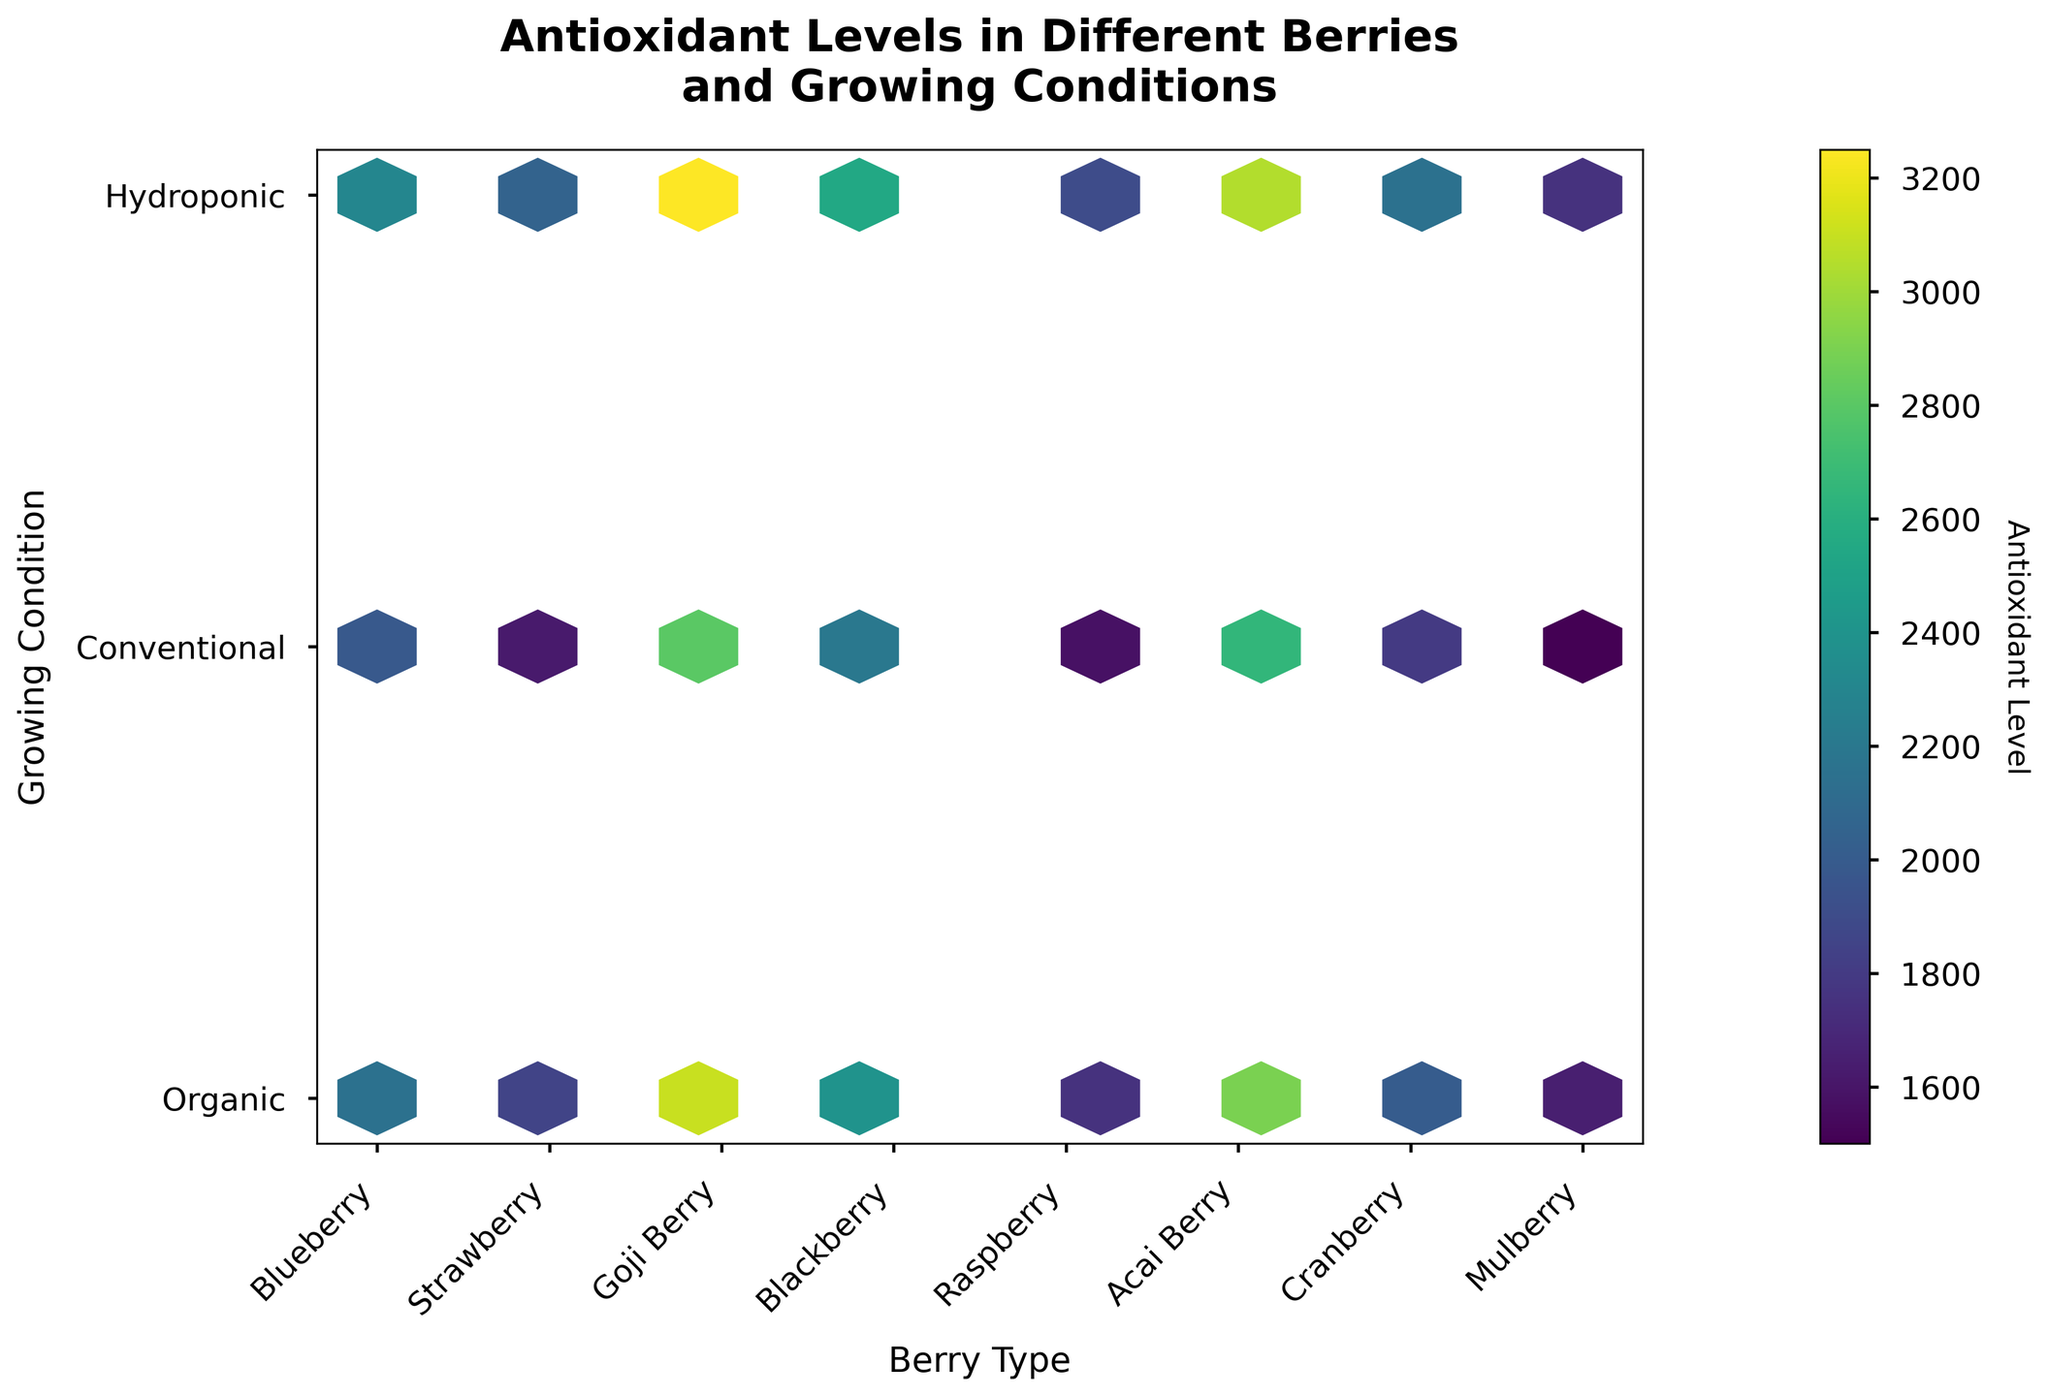How many different types of berries are displayed in the plot? The x-axis lists distinct berry types, and each tick corresponds to a different type of berry. By counting those ticks, we can determine the number of distinct berry types.
Answer: 6 How is the color of the hexagons related to the antioxidant levels? The color of the hexagons represents the antioxidant levels, with darker hexagons indicating higher antioxidant levels while lighter hexagons indicate lower levels. This information is shown in the colorbar beside the plot.
Answer: Darker colors indicate higher antioxidant levels Which berry type typically shows the highest antioxidant levels? By observing the color shades of the hexagons along the x-axis corresponding to each berry type, we can see which type has the darkest hexagons, indicating higher antioxidant levels. Goji Berries have the darkest hexagons among the berry types.
Answer: Goji Berry Compare the antioxidant levels of organic and conventional growing conditions for Acai Berry. Which is higher? Locate the hexagons corresponding to Acai Berry on the x-axis and then compare the colors of the hexagons at the positions for "Organic" and "Conventional". The darker color represents higher antioxidant levels.
Answer: Organic What is the difference in antioxidant levels between hydroponic Cranberries and organic Strawberries? Identify the color intensity of the hexagons for hydroponic Cranberries and organic Strawberries, then refer to the colorbar for their respective antioxidant levels. Subtract the level of organic Strawberries from hydroponic Cranberries.
Answer: 2000 - 1850 = 150 Which growing condition consistently shows higher antioxidant levels across all berry types? Evaluate the color intensity of hexagons for each growing condition (Organic, Conventional, Hydroponic) across all berry types. The condition that has the darkest hexagons more frequently across different berries indicates higher antioxidant levels.
Answer: Hydroponic What's the general trend in antioxidant levels between conventional and organic berries? Compare the color intensity of hexagons for conventional vs. organic labels for each berry type. Look for a consistent pattern across all the berries comparing these two conditions.
Answer: Organic berries generally show higher antioxidant levels than conventional berries For which berry type do the antioxidant levels vary the most across different growing conditions? Observe the range of color intensities for each berry type across different growing conditions. The berry type with the widest range of color changes has the most variation.
Answer: Goji Berry What's the average antioxidant level for blackberry grown under hydroponic and conventional conditions? Determine the antioxidant levels for blackberries under hydroponic and conventional conditions by referring to the colorbar. Calculate the average by adding their values and dividing by 2.
Answer: (2550 + 2200) / 2 = 2375 